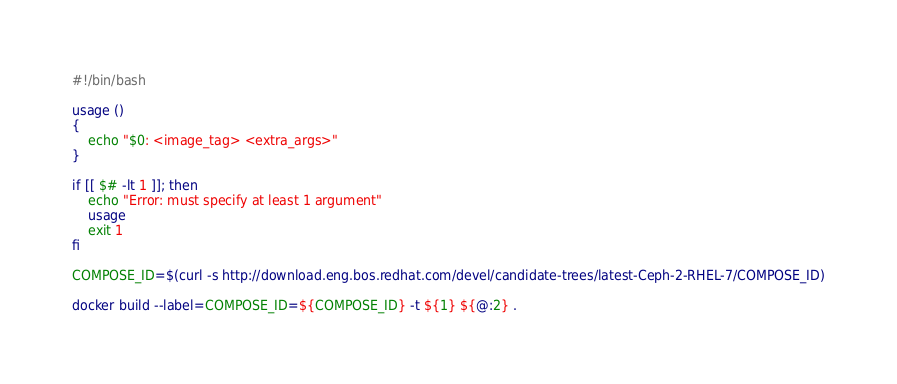<code> <loc_0><loc_0><loc_500><loc_500><_Bash_>#!/bin/bash

usage ()
{
    echo "$0: <image_tag> <extra_args>"
}

if [[ $# -lt 1 ]]; then
    echo "Error: must specify at least 1 argument"
    usage
    exit 1
fi

COMPOSE_ID=$(curl -s http://download.eng.bos.redhat.com/devel/candidate-trees/latest-Ceph-2-RHEL-7/COMPOSE_ID)

docker build --label=COMPOSE_ID=${COMPOSE_ID} -t ${1} ${@:2} .
</code> 